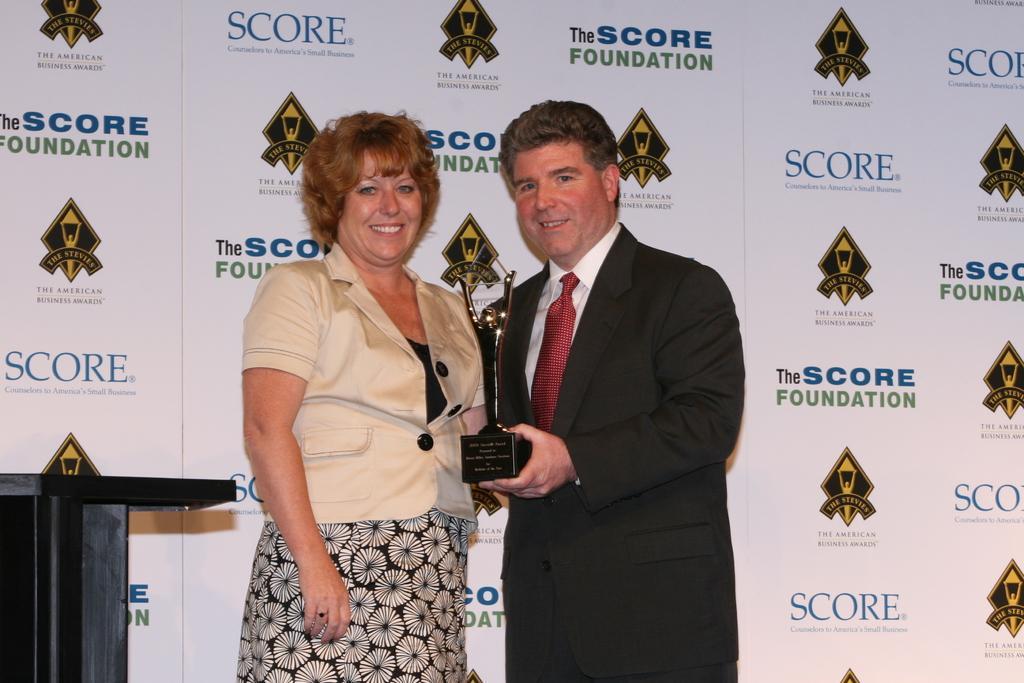Describe this image in one or two sentences. In the center of the image, we can see people standing and holding an award and one of them is wearing a coat and a tie. In the background, there is a podium and we can see some text and logos on the board. 